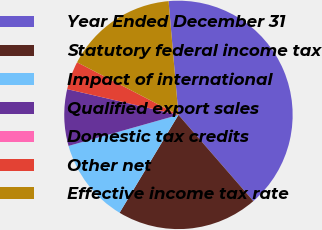Convert chart. <chart><loc_0><loc_0><loc_500><loc_500><pie_chart><fcel>Year Ended December 31<fcel>Statutory federal income tax<fcel>Impact of international<fcel>Qualified export sales<fcel>Domestic tax credits<fcel>Other net<fcel>Effective income tax rate<nl><fcel>39.99%<fcel>20.0%<fcel>12.0%<fcel>8.0%<fcel>0.0%<fcel>4.0%<fcel>16.0%<nl></chart> 